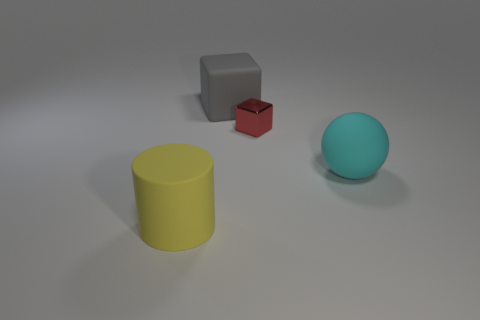Are there any objects that have the same color as the large rubber cube?
Ensure brevity in your answer.  No. There is a yellow object that is the same material as the large cyan thing; what size is it?
Keep it short and to the point. Large. What number of other things are there of the same size as the gray matte object?
Provide a succinct answer. 2. There is a large thing right of the gray rubber object; what is it made of?
Keep it short and to the point. Rubber. There is a matte thing behind the block in front of the matte object that is behind the large cyan rubber object; what is its shape?
Keep it short and to the point. Cube. Is the size of the cyan sphere the same as the cylinder?
Provide a succinct answer. Yes. What number of things are big red shiny blocks or objects on the left side of the matte block?
Offer a terse response. 1. How many objects are large matte objects behind the small metallic thing or things in front of the red thing?
Offer a very short reply. 3. Are there any small red blocks behind the small metallic object?
Make the answer very short. No. There is a big object behind the block in front of the large matte object that is behind the cyan matte thing; what is its color?
Give a very brief answer. Gray. 